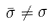Convert formula to latex. <formula><loc_0><loc_0><loc_500><loc_500>\bar { \sigma } \ne \sigma</formula> 